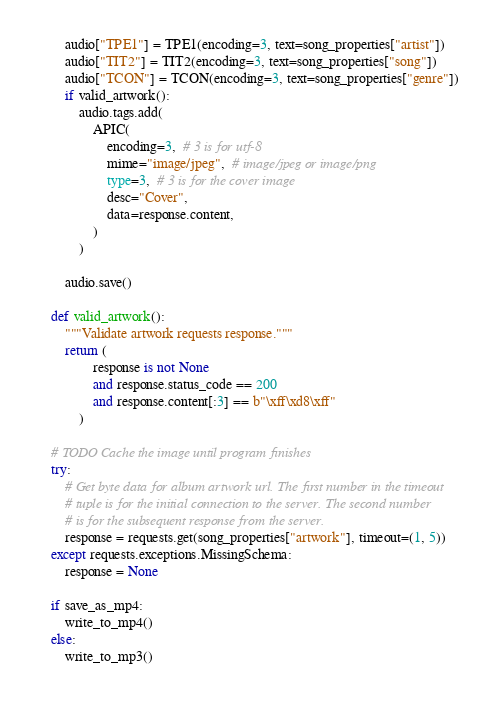<code> <loc_0><loc_0><loc_500><loc_500><_Python_>        audio["TPE1"] = TPE1(encoding=3, text=song_properties["artist"])
        audio["TIT2"] = TIT2(encoding=3, text=song_properties["song"])
        audio["TCON"] = TCON(encoding=3, text=song_properties["genre"])
        if valid_artwork():
            audio.tags.add(
                APIC(
                    encoding=3,  # 3 is for utf-8
                    mime="image/jpeg",  # image/jpeg or image/png
                    type=3,  # 3 is for the cover image
                    desc="Cover",
                    data=response.content,
                )
            )

        audio.save()

    def valid_artwork():
        """Validate artwork requests response."""
        return (
                response is not None
                and response.status_code == 200
                and response.content[:3] == b"\xff\xd8\xff"
            )

    # TODO Cache the image until program finishes
    try:
        # Get byte data for album artwork url. The first number in the timeout
        # tuple is for the initial connection to the server. The second number
        # is for the subsequent response from the server.
        response = requests.get(song_properties["artwork"], timeout=(1, 5))
    except requests.exceptions.MissingSchema:
        response = None

    if save_as_mp4:
        write_to_mp4()
    else:
        write_to_mp3()
</code> 